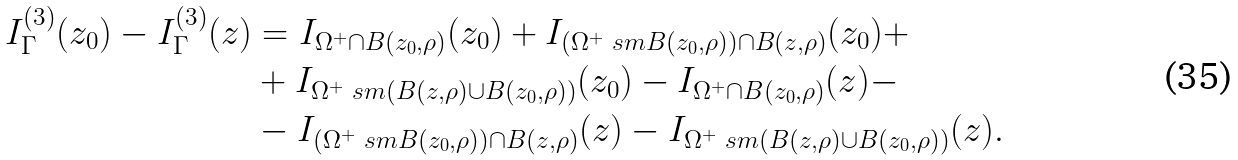<formula> <loc_0><loc_0><loc_500><loc_500>I _ { \Gamma } ^ { ( 3 ) } ( z _ { 0 } ) - I _ { \Gamma } ^ { ( 3 ) } ( z ) & = I _ { \Omega ^ { + } \cap B ( z _ { 0 } , \rho ) } ( z _ { 0 } ) + I _ { ( \Omega ^ { + } \ s m B ( z _ { 0 } , \rho ) ) \cap B ( z , \rho ) } ( z _ { 0 } ) + \\ & + I _ { \Omega ^ { + } \ s m ( B ( z , \rho ) \cup B ( z _ { 0 } , \rho ) ) } ( z _ { 0 } ) - I _ { \Omega ^ { + } \cap B ( z _ { 0 } , \rho ) } ( z ) - \\ & - I _ { ( \Omega ^ { + } \ s m B ( z _ { 0 } , \rho ) ) \cap B ( z , \rho ) } ( z ) - I _ { \Omega ^ { + } \ s m ( B ( z , \rho ) \cup B ( z _ { 0 } , \rho ) ) } ( z ) .</formula> 